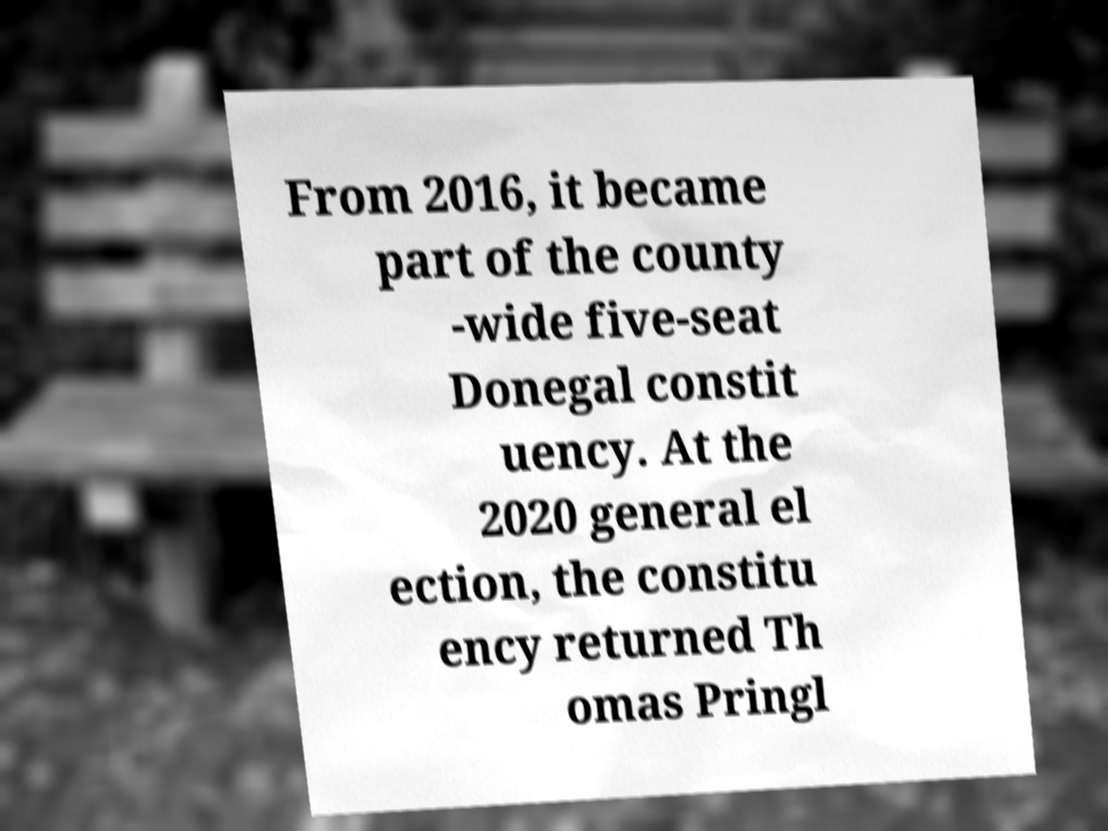I need the written content from this picture converted into text. Can you do that? From 2016, it became part of the county -wide five-seat Donegal constit uency. At the 2020 general el ection, the constitu ency returned Th omas Pringl 